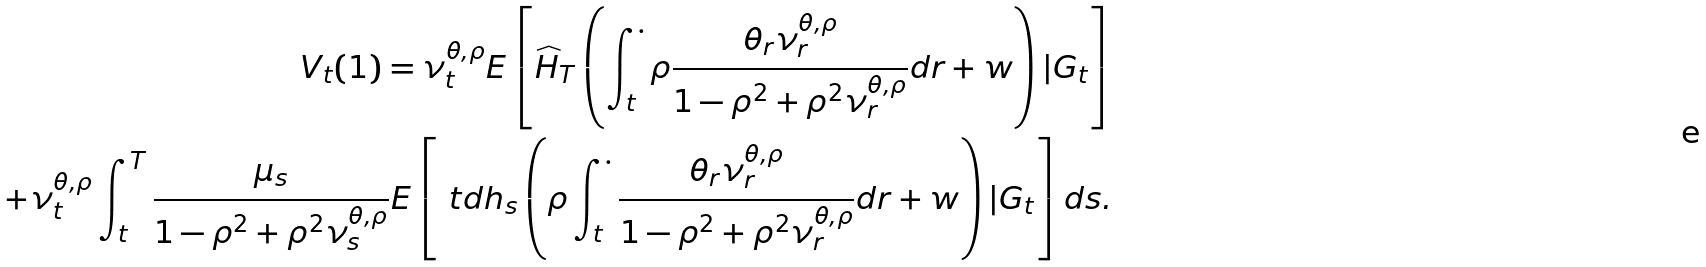Convert formula to latex. <formula><loc_0><loc_0><loc_500><loc_500>V _ { t } ( 1 ) = \nu _ { t } ^ { \theta , \rho } E \left [ \widehat { H } _ { T } \left ( \int _ { t } ^ { \cdot } \rho \frac { \theta _ { r } \nu _ { r } ^ { \theta , \rho } } { 1 - \rho ^ { 2 } + \rho ^ { 2 } \nu _ { r } ^ { \theta , \rho } } d r + w \right ) | { G } _ { t } \right ] \\ + \nu _ { t } ^ { \theta , \rho } \int _ { t } ^ { T } \frac { \mu _ { s } } { 1 - \rho ^ { 2 } + \rho ^ { 2 } \nu _ { s } ^ { \theta , \rho } } E \left [ \ t d { h } _ { s } \left ( \rho \int _ { t } ^ { \cdot } \frac { \theta _ { r } \nu _ { r } ^ { \theta , \rho } } { 1 - \rho ^ { 2 } + \rho ^ { 2 } \nu _ { r } ^ { \theta , \rho } } d r + w \right ) | { G } _ { t } \right ] d s .</formula> 